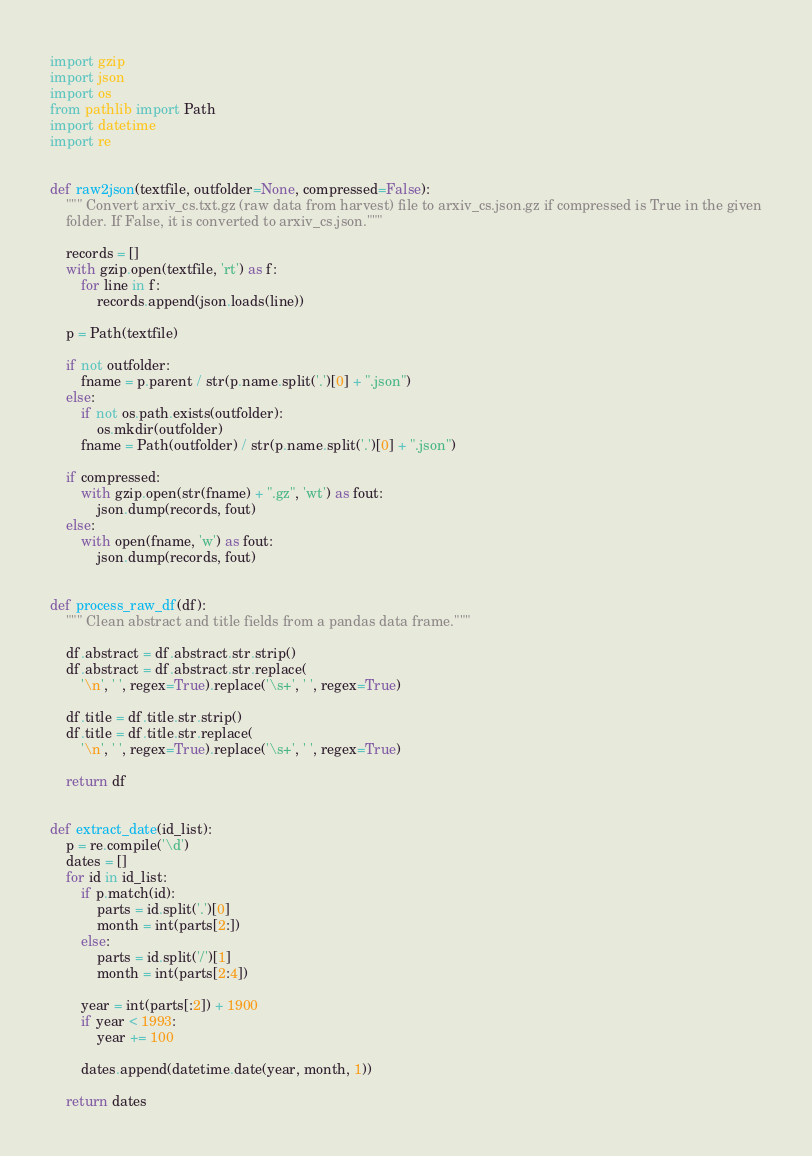<code> <loc_0><loc_0><loc_500><loc_500><_Python_>import gzip
import json
import os
from pathlib import Path
import datetime
import re


def raw2json(textfile, outfolder=None, compressed=False):
    """ Convert arxiv_cs.txt.gz (raw data from harvest) file to arxiv_cs.json.gz if compressed is True in the given
    folder. If False, it is converted to arxiv_cs.json."""

    records = []
    with gzip.open(textfile, 'rt') as f:
        for line in f:
            records.append(json.loads(line))

    p = Path(textfile)

    if not outfolder:
        fname = p.parent / str(p.name.split('.')[0] + ".json")
    else:
        if not os.path.exists(outfolder):
            os.mkdir(outfolder)
        fname = Path(outfolder) / str(p.name.split('.')[0] + ".json")

    if compressed:
        with gzip.open(str(fname) + ".gz", 'wt') as fout:
            json.dump(records, fout)
    else:
        with open(fname, 'w') as fout:
            json.dump(records, fout)


def process_raw_df(df):
    """ Clean abstract and title fields from a pandas data frame."""

    df.abstract = df.abstract.str.strip()
    df.abstract = df.abstract.str.replace(
        '\n', ' ', regex=True).replace('\s+', ' ', regex=True)

    df.title = df.title.str.strip()
    df.title = df.title.str.replace(
        '\n', ' ', regex=True).replace('\s+', ' ', regex=True)

    return df


def extract_date(id_list):
    p = re.compile('\d')
    dates = []
    for id in id_list:
        if p.match(id):
            parts = id.split('.')[0]
            month = int(parts[2:])
        else:
            parts = id.split('/')[1]
            month = int(parts[2:4])

        year = int(parts[:2]) + 1900
        if year < 1993:
            year += 100

        dates.append(datetime.date(year, month, 1))

    return dates
</code> 